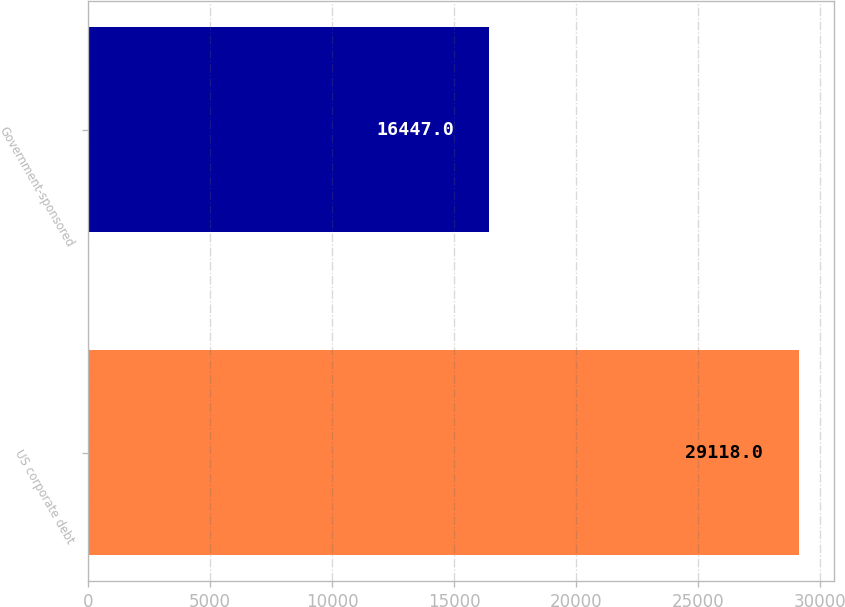Convert chart. <chart><loc_0><loc_0><loc_500><loc_500><bar_chart><fcel>US corporate debt<fcel>Government-sponsored<nl><fcel>29118<fcel>16447<nl></chart> 